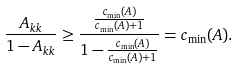<formula> <loc_0><loc_0><loc_500><loc_500>\frac { A _ { k k } } { 1 - A _ { k k } } \geq \frac { \frac { c _ { \min } ( A ) } { c _ { \min } ( A ) + 1 } } { 1 - \frac { c _ { \min } ( A ) } { c _ { \min } ( A ) + 1 } } = c _ { \min } ( A ) .</formula> 